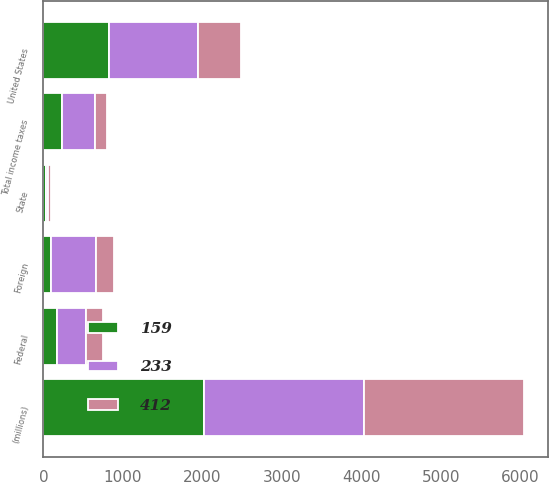<chart> <loc_0><loc_0><loc_500><loc_500><stacked_bar_chart><ecel><fcel>(millions)<fcel>United States<fcel>Foreign<fcel>Federal<fcel>State<fcel>Total income taxes<nl><fcel>233<fcel>2017<fcel>1109<fcel>565<fcel>358<fcel>31<fcel>412<nl><fcel>159<fcel>2016<fcel>830<fcel>97<fcel>173<fcel>26<fcel>233<nl><fcel>412<fcel>2015<fcel>551<fcel>222<fcel>212<fcel>42<fcel>159<nl></chart> 